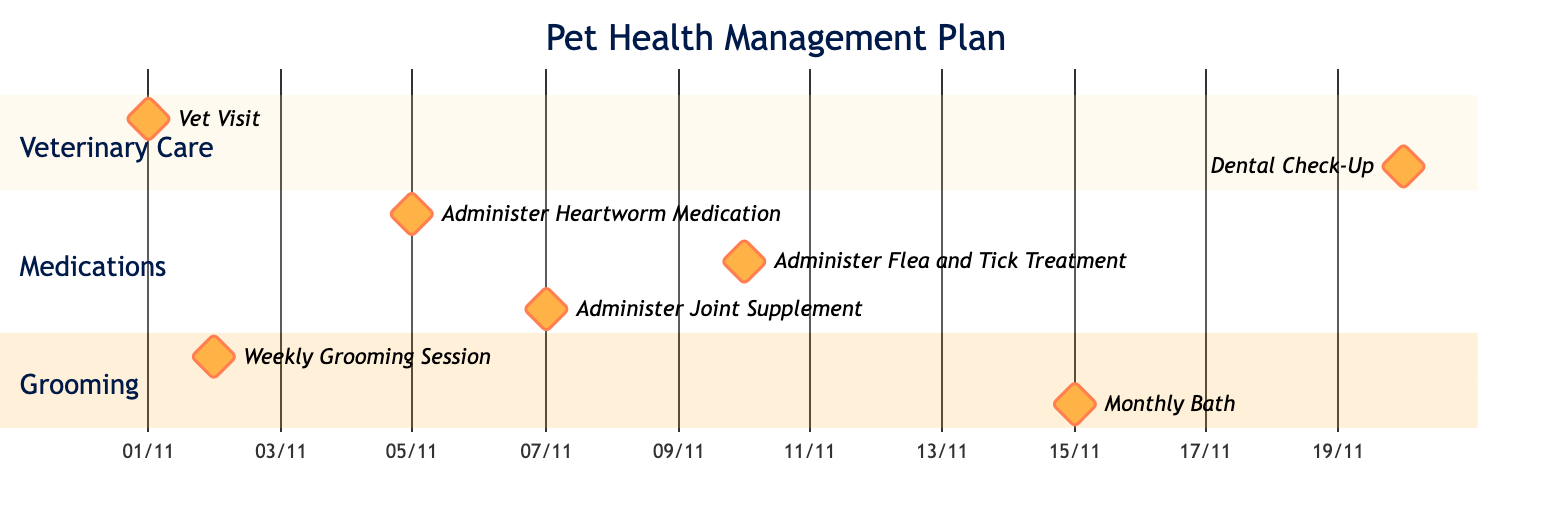What task is scheduled for November 1, 2023? The diagram indicates that on November 1, 2023, there is a task labeled "Vet Visit." This task is marked as a milestone in the Veterinary Care section of the diagram.
Answer: Vet Visit How many grooming sessions are planned in November? Upon reviewing the Grooming section, I count two grooming tasks: "Weekly Grooming Session" on November 2 and "Monthly Bath" on November 15.
Answer: 2 What is the timing for administering the Joint Supplement? The diagram shows the "Administer Joint Supplement" task scheduled for November 7, 2023, marking it as a milestone in the Medications section.
Answer: November 7 Which medication is administered on November 5, 2023? Referring to the Medications section, on November 5, 2023, the task labeled "Administer Heartworm Medication" is identified. This specifies which medication is to be given on that date.
Answer: Heartworm Medication What is the last grooming activity scheduled in November? By examining the Grooming section, the last scheduled task is "Monthly Bath" on November 15, making it the final grooming activity for the month.
Answer: Monthly Bath How many veterinary care milestones are indicated in the diagram? The Veterinary Care section lists two milestones: "Vet Visit" and "Dental Check-Up." Therefore, I conclude that there are two veterinary care milestones present in the diagram.
Answer: 2 What is the interval between the Weekly Grooming Session and the Monthly Bath? The Weekly Grooming Session takes place on November 2, and the Monthly Bath is scheduled for November 15. To find the interval, one counts the days from the 2nd to the 15th, which is 13 days.
Answer: 13 days What type of treatment is scheduled for November 10, 2023? By checking the Medications section, I find the task "Administer Flea and Tick Treatment," indicating that this particular treatment is scheduled for November 10, 2023.
Answer: Flea and Tick Treatment 